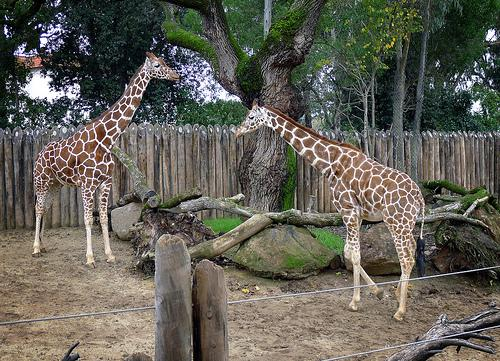Question: how many giraffes are shown?
Choices:
A. 2.
B. 6.
C. 5.
D. 4.
Answer with the letter. Answer: A Question: where is this picture taken?
Choices:
A. A playground.
B. A park.
C. The beach.
D. A zoo.
Answer with the letter. Answer: D Question: where are the giraffes standing?
Choices:
A. By the fence.
B. In a field.
C. Next to the building.
D. Near a tree.
Answer with the letter. Answer: D 